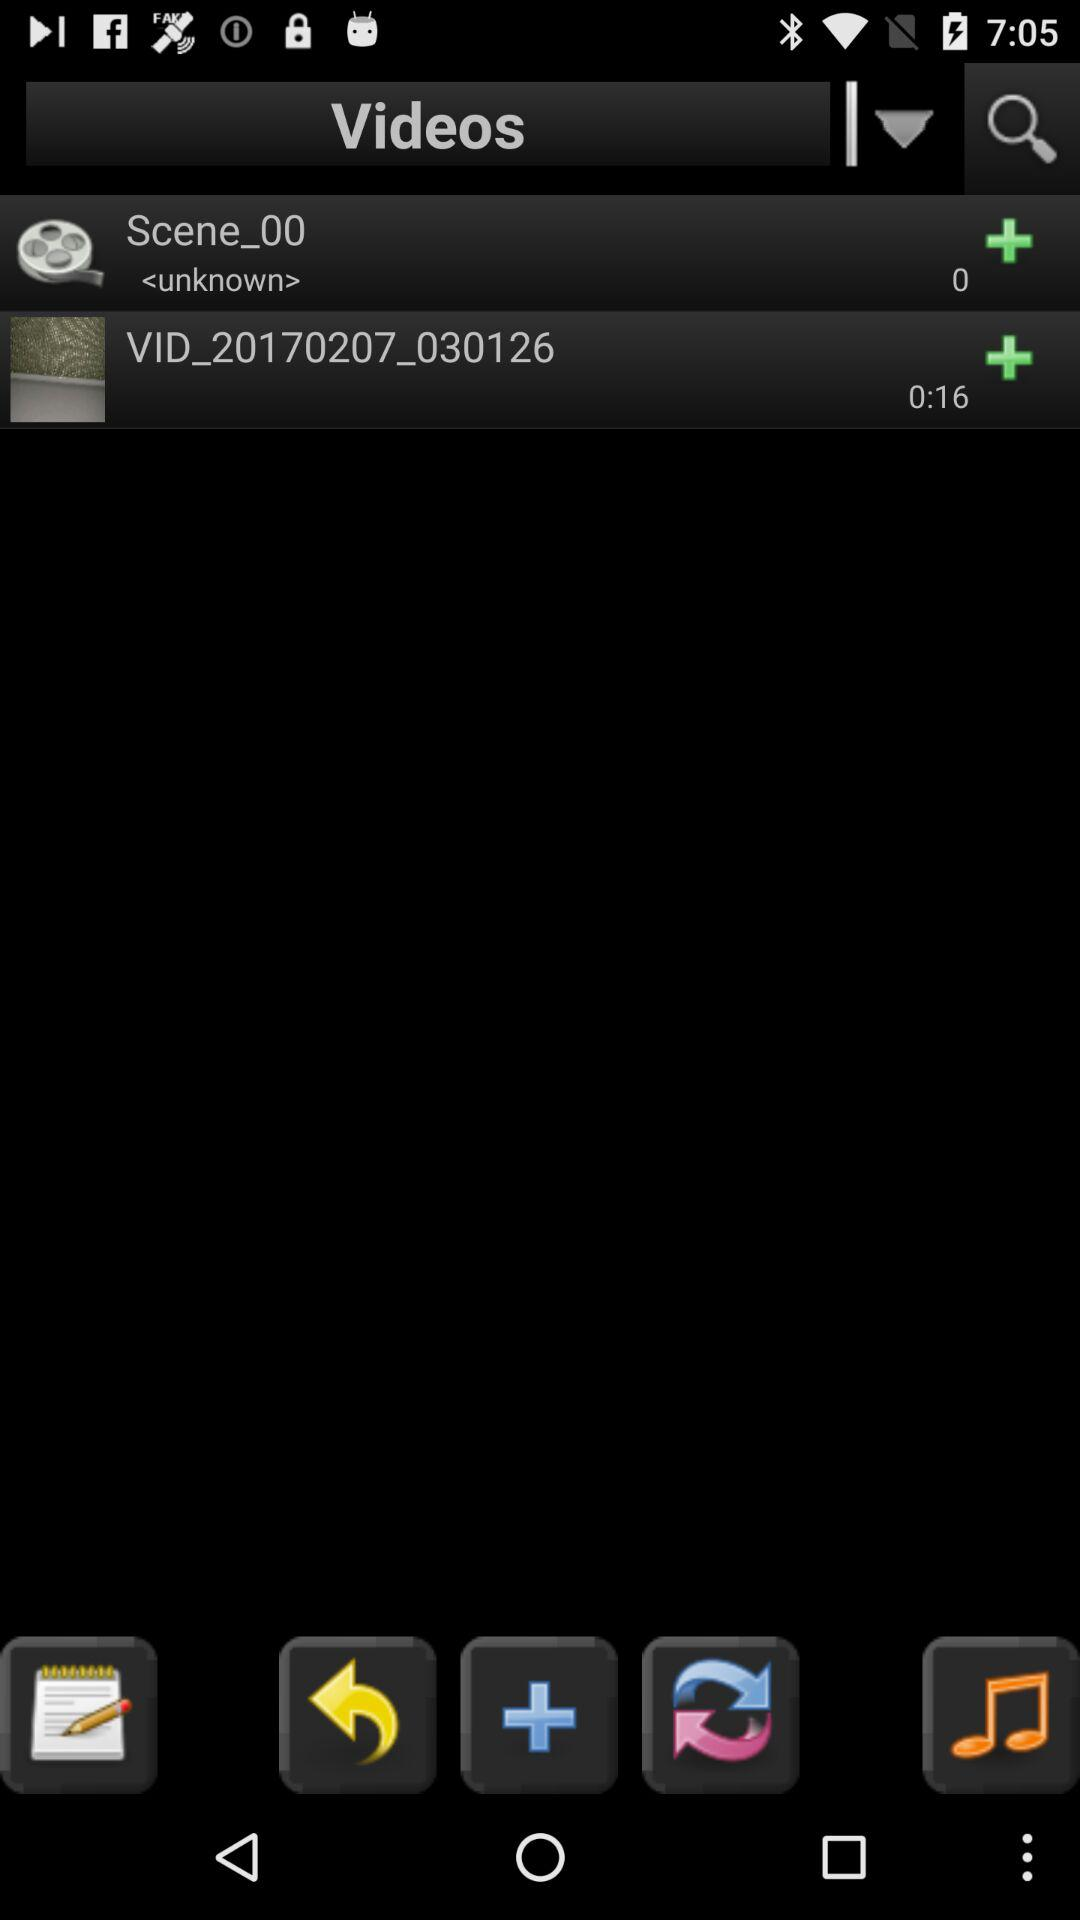What's the name of the video? The names of the videos are "Scene_00" and "VID_20170207_030126". 